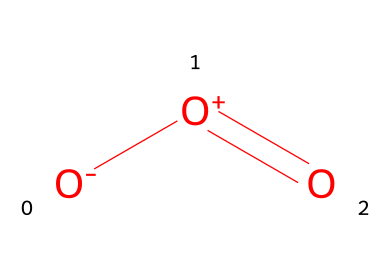What is the name of this chemical? The chemical structure corresponds to ozone, which is commonly represented by the SMILES notation [O-][O+]=O, depicting three oxygen atoms arranged in a bent shape.
Answer: ozone How many oxygen atoms are present in this molecule? Examining the SMILES notation [O-][O+]=O reveals three oxygen atoms indicated by the three 'O's.
Answer: three What type of bonding is present between the oxygen atoms in ozone? The structure shows a single double bond (indicated by the '=' sign) and a single bond (indicated by the adjacent atoms), thus it has both single and double bonds.
Answer: single and double What is the charge on the first oxygen atom in the ozone molecule? The SMILES representation shows that the first oxygen is connected to a negative charge ([O-]), indicating it has an extra electron.
Answer: negative Is ozone an oxidizer or reducer? Ozone is known for its strong oxidizing properties due to the presence of energized oxygen atoms that can accept electrons from other substances.
Answer: oxidizer What is the molecular geometry of ozone? The arrangement of three oxygen atoms leads to a bent molecular geometry, similar to that of water due to lone pair effects.
Answer: bent How does the oxidation potential of ozone compare to that of molecular oxygen? Ozone has a higher oxidation potential than molecular oxygen due to its ability to easily release oxygen radicals, making it a stronger oxidizing agent.
Answer: higher 